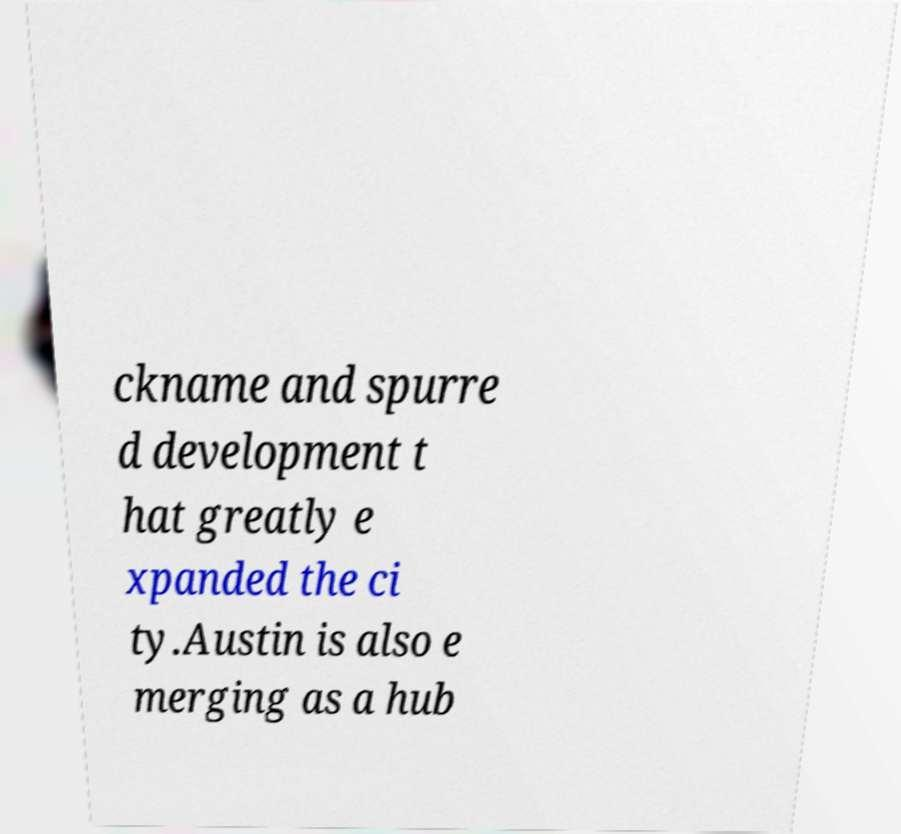Please read and relay the text visible in this image. What does it say? ckname and spurre d development t hat greatly e xpanded the ci ty.Austin is also e merging as a hub 